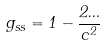<formula> <loc_0><loc_0><loc_500><loc_500>g _ { s s } = 1 - \frac { 2 \Phi } { c ^ { 2 } }</formula> 